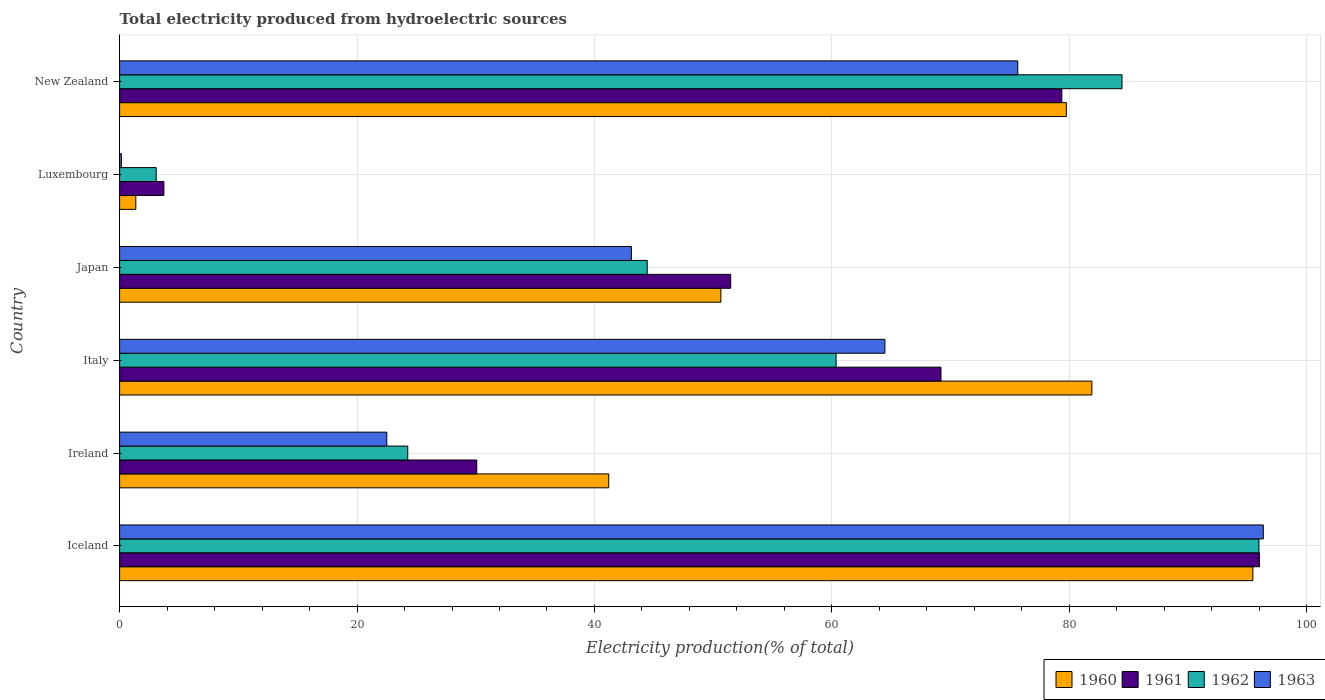How many different coloured bars are there?
Your answer should be very brief. 4. How many bars are there on the 5th tick from the bottom?
Your response must be concise. 4. In how many cases, is the number of bars for a given country not equal to the number of legend labels?
Provide a short and direct response. 0. What is the total electricity produced in 1963 in Ireland?
Give a very brief answer. 22.51. Across all countries, what is the maximum total electricity produced in 1960?
Give a very brief answer. 95.46. Across all countries, what is the minimum total electricity produced in 1963?
Make the answer very short. 0.15. In which country was the total electricity produced in 1963 minimum?
Your answer should be compact. Luxembourg. What is the total total electricity produced in 1960 in the graph?
Provide a short and direct response. 350.33. What is the difference between the total electricity produced in 1963 in Luxembourg and that in New Zealand?
Offer a very short reply. -75.51. What is the difference between the total electricity produced in 1963 in Ireland and the total electricity produced in 1962 in Iceland?
Your answer should be compact. -73.47. What is the average total electricity produced in 1961 per country?
Make the answer very short. 54.98. What is the difference between the total electricity produced in 1963 and total electricity produced in 1961 in Japan?
Provide a succinct answer. -8.36. What is the ratio of the total electricity produced in 1963 in Ireland to that in Japan?
Make the answer very short. 0.52. Is the difference between the total electricity produced in 1963 in Ireland and Italy greater than the difference between the total electricity produced in 1961 in Ireland and Italy?
Give a very brief answer. No. What is the difference between the highest and the second highest total electricity produced in 1963?
Give a very brief answer. 20.68. What is the difference between the highest and the lowest total electricity produced in 1962?
Your response must be concise. 92.89. In how many countries, is the total electricity produced in 1962 greater than the average total electricity produced in 1962 taken over all countries?
Keep it short and to the point. 3. Is it the case that in every country, the sum of the total electricity produced in 1960 and total electricity produced in 1961 is greater than the sum of total electricity produced in 1962 and total electricity produced in 1963?
Offer a terse response. No. What does the 3rd bar from the top in Ireland represents?
Offer a terse response. 1961. Are all the bars in the graph horizontal?
Your answer should be compact. Yes. Does the graph contain grids?
Ensure brevity in your answer.  Yes. Where does the legend appear in the graph?
Keep it short and to the point. Bottom right. How many legend labels are there?
Give a very brief answer. 4. What is the title of the graph?
Provide a succinct answer. Total electricity produced from hydroelectric sources. What is the Electricity production(% of total) of 1960 in Iceland?
Give a very brief answer. 95.46. What is the Electricity production(% of total) of 1961 in Iceland?
Offer a terse response. 96.02. What is the Electricity production(% of total) in 1962 in Iceland?
Give a very brief answer. 95.97. What is the Electricity production(% of total) in 1963 in Iceland?
Keep it short and to the point. 96.34. What is the Electricity production(% of total) in 1960 in Ireland?
Your answer should be compact. 41.2. What is the Electricity production(% of total) in 1961 in Ireland?
Provide a succinct answer. 30.09. What is the Electricity production(% of total) of 1962 in Ireland?
Offer a terse response. 24.27. What is the Electricity production(% of total) in 1963 in Ireland?
Provide a short and direct response. 22.51. What is the Electricity production(% of total) of 1960 in Italy?
Your response must be concise. 81.9. What is the Electricity production(% of total) of 1961 in Italy?
Provide a short and direct response. 69.19. What is the Electricity production(% of total) in 1962 in Italy?
Keep it short and to the point. 60.35. What is the Electricity production(% of total) in 1963 in Italy?
Provide a short and direct response. 64.47. What is the Electricity production(% of total) of 1960 in Japan?
Offer a very short reply. 50.65. What is the Electricity production(% of total) in 1961 in Japan?
Make the answer very short. 51.48. What is the Electricity production(% of total) in 1962 in Japan?
Your response must be concise. 44.44. What is the Electricity production(% of total) of 1963 in Japan?
Keep it short and to the point. 43.11. What is the Electricity production(% of total) in 1960 in Luxembourg?
Your response must be concise. 1.37. What is the Electricity production(% of total) of 1961 in Luxembourg?
Offer a terse response. 3.73. What is the Electricity production(% of total) in 1962 in Luxembourg?
Offer a very short reply. 3.08. What is the Electricity production(% of total) of 1963 in Luxembourg?
Keep it short and to the point. 0.15. What is the Electricity production(% of total) of 1960 in New Zealand?
Keep it short and to the point. 79.75. What is the Electricity production(% of total) in 1961 in New Zealand?
Make the answer very short. 79.37. What is the Electricity production(% of total) in 1962 in New Zealand?
Ensure brevity in your answer.  84.44. What is the Electricity production(% of total) of 1963 in New Zealand?
Your answer should be compact. 75.66. Across all countries, what is the maximum Electricity production(% of total) in 1960?
Offer a very short reply. 95.46. Across all countries, what is the maximum Electricity production(% of total) in 1961?
Keep it short and to the point. 96.02. Across all countries, what is the maximum Electricity production(% of total) of 1962?
Provide a succinct answer. 95.97. Across all countries, what is the maximum Electricity production(% of total) of 1963?
Keep it short and to the point. 96.34. Across all countries, what is the minimum Electricity production(% of total) of 1960?
Your answer should be compact. 1.37. Across all countries, what is the minimum Electricity production(% of total) of 1961?
Your response must be concise. 3.73. Across all countries, what is the minimum Electricity production(% of total) of 1962?
Your answer should be compact. 3.08. Across all countries, what is the minimum Electricity production(% of total) of 1963?
Offer a terse response. 0.15. What is the total Electricity production(% of total) of 1960 in the graph?
Provide a short and direct response. 350.33. What is the total Electricity production(% of total) in 1961 in the graph?
Make the answer very short. 329.87. What is the total Electricity production(% of total) of 1962 in the graph?
Keep it short and to the point. 312.57. What is the total Electricity production(% of total) in 1963 in the graph?
Your response must be concise. 302.24. What is the difference between the Electricity production(% of total) in 1960 in Iceland and that in Ireland?
Keep it short and to the point. 54.26. What is the difference between the Electricity production(% of total) in 1961 in Iceland and that in Ireland?
Offer a very short reply. 65.93. What is the difference between the Electricity production(% of total) of 1962 in Iceland and that in Ireland?
Ensure brevity in your answer.  71.7. What is the difference between the Electricity production(% of total) in 1963 in Iceland and that in Ireland?
Offer a very short reply. 73.83. What is the difference between the Electricity production(% of total) in 1960 in Iceland and that in Italy?
Keep it short and to the point. 13.56. What is the difference between the Electricity production(% of total) of 1961 in Iceland and that in Italy?
Provide a short and direct response. 26.83. What is the difference between the Electricity production(% of total) in 1962 in Iceland and that in Italy?
Ensure brevity in your answer.  35.62. What is the difference between the Electricity production(% of total) in 1963 in Iceland and that in Italy?
Your response must be concise. 31.87. What is the difference between the Electricity production(% of total) of 1960 in Iceland and that in Japan?
Provide a short and direct response. 44.81. What is the difference between the Electricity production(% of total) of 1961 in Iceland and that in Japan?
Provide a short and direct response. 44.54. What is the difference between the Electricity production(% of total) in 1962 in Iceland and that in Japan?
Offer a terse response. 51.53. What is the difference between the Electricity production(% of total) in 1963 in Iceland and that in Japan?
Offer a very short reply. 53.23. What is the difference between the Electricity production(% of total) in 1960 in Iceland and that in Luxembourg?
Offer a terse response. 94.1. What is the difference between the Electricity production(% of total) in 1961 in Iceland and that in Luxembourg?
Offer a very short reply. 92.29. What is the difference between the Electricity production(% of total) of 1962 in Iceland and that in Luxembourg?
Give a very brief answer. 92.89. What is the difference between the Electricity production(% of total) in 1963 in Iceland and that in Luxembourg?
Ensure brevity in your answer.  96.19. What is the difference between the Electricity production(% of total) in 1960 in Iceland and that in New Zealand?
Give a very brief answer. 15.71. What is the difference between the Electricity production(% of total) of 1961 in Iceland and that in New Zealand?
Provide a short and direct response. 16.65. What is the difference between the Electricity production(% of total) of 1962 in Iceland and that in New Zealand?
Keep it short and to the point. 11.54. What is the difference between the Electricity production(% of total) in 1963 in Iceland and that in New Zealand?
Provide a short and direct response. 20.68. What is the difference between the Electricity production(% of total) in 1960 in Ireland and that in Italy?
Your answer should be very brief. -40.7. What is the difference between the Electricity production(% of total) in 1961 in Ireland and that in Italy?
Provide a succinct answer. -39.1. What is the difference between the Electricity production(% of total) of 1962 in Ireland and that in Italy?
Give a very brief answer. -36.08. What is the difference between the Electricity production(% of total) of 1963 in Ireland and that in Italy?
Offer a terse response. -41.96. What is the difference between the Electricity production(% of total) of 1960 in Ireland and that in Japan?
Offer a very short reply. -9.45. What is the difference between the Electricity production(% of total) in 1961 in Ireland and that in Japan?
Your answer should be very brief. -21.39. What is the difference between the Electricity production(% of total) of 1962 in Ireland and that in Japan?
Your answer should be compact. -20.17. What is the difference between the Electricity production(% of total) of 1963 in Ireland and that in Japan?
Your answer should be compact. -20.61. What is the difference between the Electricity production(% of total) in 1960 in Ireland and that in Luxembourg?
Make the answer very short. 39.84. What is the difference between the Electricity production(% of total) of 1961 in Ireland and that in Luxembourg?
Your answer should be very brief. 26.36. What is the difference between the Electricity production(% of total) in 1962 in Ireland and that in Luxembourg?
Your response must be concise. 21.19. What is the difference between the Electricity production(% of total) of 1963 in Ireland and that in Luxembourg?
Offer a very short reply. 22.36. What is the difference between the Electricity production(% of total) of 1960 in Ireland and that in New Zealand?
Provide a succinct answer. -38.55. What is the difference between the Electricity production(% of total) in 1961 in Ireland and that in New Zealand?
Offer a very short reply. -49.29. What is the difference between the Electricity production(% of total) in 1962 in Ireland and that in New Zealand?
Your answer should be compact. -60.17. What is the difference between the Electricity production(% of total) in 1963 in Ireland and that in New Zealand?
Ensure brevity in your answer.  -53.15. What is the difference between the Electricity production(% of total) of 1960 in Italy and that in Japan?
Offer a terse response. 31.25. What is the difference between the Electricity production(% of total) in 1961 in Italy and that in Japan?
Ensure brevity in your answer.  17.71. What is the difference between the Electricity production(% of total) of 1962 in Italy and that in Japan?
Keep it short and to the point. 15.91. What is the difference between the Electricity production(% of total) in 1963 in Italy and that in Japan?
Keep it short and to the point. 21.35. What is the difference between the Electricity production(% of total) in 1960 in Italy and that in Luxembourg?
Offer a very short reply. 80.53. What is the difference between the Electricity production(% of total) of 1961 in Italy and that in Luxembourg?
Provide a succinct answer. 65.46. What is the difference between the Electricity production(% of total) of 1962 in Italy and that in Luxembourg?
Your answer should be compact. 57.27. What is the difference between the Electricity production(% of total) in 1963 in Italy and that in Luxembourg?
Make the answer very short. 64.32. What is the difference between the Electricity production(% of total) of 1960 in Italy and that in New Zealand?
Offer a very short reply. 2.15. What is the difference between the Electricity production(% of total) of 1961 in Italy and that in New Zealand?
Your answer should be very brief. -10.18. What is the difference between the Electricity production(% of total) in 1962 in Italy and that in New Zealand?
Offer a terse response. -24.08. What is the difference between the Electricity production(% of total) of 1963 in Italy and that in New Zealand?
Your answer should be very brief. -11.19. What is the difference between the Electricity production(% of total) in 1960 in Japan and that in Luxembourg?
Provide a short and direct response. 49.28. What is the difference between the Electricity production(% of total) in 1961 in Japan and that in Luxembourg?
Give a very brief answer. 47.75. What is the difference between the Electricity production(% of total) of 1962 in Japan and that in Luxembourg?
Make the answer very short. 41.36. What is the difference between the Electricity production(% of total) in 1963 in Japan and that in Luxembourg?
Your answer should be compact. 42.97. What is the difference between the Electricity production(% of total) in 1960 in Japan and that in New Zealand?
Offer a very short reply. -29.1. What is the difference between the Electricity production(% of total) of 1961 in Japan and that in New Zealand?
Offer a very short reply. -27.9. What is the difference between the Electricity production(% of total) of 1962 in Japan and that in New Zealand?
Offer a very short reply. -39.99. What is the difference between the Electricity production(% of total) in 1963 in Japan and that in New Zealand?
Ensure brevity in your answer.  -32.54. What is the difference between the Electricity production(% of total) of 1960 in Luxembourg and that in New Zealand?
Offer a very short reply. -78.38. What is the difference between the Electricity production(% of total) of 1961 in Luxembourg and that in New Zealand?
Ensure brevity in your answer.  -75.64. What is the difference between the Electricity production(% of total) in 1962 in Luxembourg and that in New Zealand?
Provide a succinct answer. -81.36. What is the difference between the Electricity production(% of total) in 1963 in Luxembourg and that in New Zealand?
Give a very brief answer. -75.51. What is the difference between the Electricity production(% of total) in 1960 in Iceland and the Electricity production(% of total) in 1961 in Ireland?
Make the answer very short. 65.38. What is the difference between the Electricity production(% of total) of 1960 in Iceland and the Electricity production(% of total) of 1962 in Ireland?
Give a very brief answer. 71.19. What is the difference between the Electricity production(% of total) in 1960 in Iceland and the Electricity production(% of total) in 1963 in Ireland?
Offer a very short reply. 72.95. What is the difference between the Electricity production(% of total) in 1961 in Iceland and the Electricity production(% of total) in 1962 in Ireland?
Provide a short and direct response. 71.75. What is the difference between the Electricity production(% of total) of 1961 in Iceland and the Electricity production(% of total) of 1963 in Ireland?
Your answer should be compact. 73.51. What is the difference between the Electricity production(% of total) of 1962 in Iceland and the Electricity production(% of total) of 1963 in Ireland?
Make the answer very short. 73.47. What is the difference between the Electricity production(% of total) in 1960 in Iceland and the Electricity production(% of total) in 1961 in Italy?
Give a very brief answer. 26.27. What is the difference between the Electricity production(% of total) in 1960 in Iceland and the Electricity production(% of total) in 1962 in Italy?
Give a very brief answer. 35.11. What is the difference between the Electricity production(% of total) in 1960 in Iceland and the Electricity production(% of total) in 1963 in Italy?
Ensure brevity in your answer.  30.99. What is the difference between the Electricity production(% of total) of 1961 in Iceland and the Electricity production(% of total) of 1962 in Italy?
Make the answer very short. 35.67. What is the difference between the Electricity production(% of total) in 1961 in Iceland and the Electricity production(% of total) in 1963 in Italy?
Your answer should be compact. 31.55. What is the difference between the Electricity production(% of total) in 1962 in Iceland and the Electricity production(% of total) in 1963 in Italy?
Offer a very short reply. 31.51. What is the difference between the Electricity production(% of total) of 1960 in Iceland and the Electricity production(% of total) of 1961 in Japan?
Keep it short and to the point. 43.99. What is the difference between the Electricity production(% of total) of 1960 in Iceland and the Electricity production(% of total) of 1962 in Japan?
Your response must be concise. 51.02. What is the difference between the Electricity production(% of total) of 1960 in Iceland and the Electricity production(% of total) of 1963 in Japan?
Your answer should be compact. 52.35. What is the difference between the Electricity production(% of total) in 1961 in Iceland and the Electricity production(% of total) in 1962 in Japan?
Ensure brevity in your answer.  51.58. What is the difference between the Electricity production(% of total) in 1961 in Iceland and the Electricity production(% of total) in 1963 in Japan?
Your answer should be compact. 52.91. What is the difference between the Electricity production(% of total) in 1962 in Iceland and the Electricity production(% of total) in 1963 in Japan?
Make the answer very short. 52.86. What is the difference between the Electricity production(% of total) in 1960 in Iceland and the Electricity production(% of total) in 1961 in Luxembourg?
Offer a very short reply. 91.73. What is the difference between the Electricity production(% of total) of 1960 in Iceland and the Electricity production(% of total) of 1962 in Luxembourg?
Offer a very short reply. 92.38. What is the difference between the Electricity production(% of total) of 1960 in Iceland and the Electricity production(% of total) of 1963 in Luxembourg?
Offer a terse response. 95.32. What is the difference between the Electricity production(% of total) in 1961 in Iceland and the Electricity production(% of total) in 1962 in Luxembourg?
Provide a short and direct response. 92.94. What is the difference between the Electricity production(% of total) in 1961 in Iceland and the Electricity production(% of total) in 1963 in Luxembourg?
Offer a terse response. 95.87. What is the difference between the Electricity production(% of total) of 1962 in Iceland and the Electricity production(% of total) of 1963 in Luxembourg?
Your answer should be very brief. 95.83. What is the difference between the Electricity production(% of total) in 1960 in Iceland and the Electricity production(% of total) in 1961 in New Zealand?
Your answer should be very brief. 16.09. What is the difference between the Electricity production(% of total) of 1960 in Iceland and the Electricity production(% of total) of 1962 in New Zealand?
Give a very brief answer. 11.02. What is the difference between the Electricity production(% of total) in 1960 in Iceland and the Electricity production(% of total) in 1963 in New Zealand?
Provide a short and direct response. 19.8. What is the difference between the Electricity production(% of total) of 1961 in Iceland and the Electricity production(% of total) of 1962 in New Zealand?
Your answer should be compact. 11.58. What is the difference between the Electricity production(% of total) of 1961 in Iceland and the Electricity production(% of total) of 1963 in New Zealand?
Your answer should be very brief. 20.36. What is the difference between the Electricity production(% of total) of 1962 in Iceland and the Electricity production(% of total) of 1963 in New Zealand?
Ensure brevity in your answer.  20.32. What is the difference between the Electricity production(% of total) of 1960 in Ireland and the Electricity production(% of total) of 1961 in Italy?
Make the answer very short. -27.99. What is the difference between the Electricity production(% of total) in 1960 in Ireland and the Electricity production(% of total) in 1962 in Italy?
Make the answer very short. -19.15. What is the difference between the Electricity production(% of total) in 1960 in Ireland and the Electricity production(% of total) in 1963 in Italy?
Give a very brief answer. -23.27. What is the difference between the Electricity production(% of total) of 1961 in Ireland and the Electricity production(% of total) of 1962 in Italy?
Offer a terse response. -30.27. What is the difference between the Electricity production(% of total) in 1961 in Ireland and the Electricity production(% of total) in 1963 in Italy?
Keep it short and to the point. -34.38. What is the difference between the Electricity production(% of total) of 1962 in Ireland and the Electricity production(% of total) of 1963 in Italy?
Offer a very short reply. -40.2. What is the difference between the Electricity production(% of total) in 1960 in Ireland and the Electricity production(% of total) in 1961 in Japan?
Your answer should be very brief. -10.27. What is the difference between the Electricity production(% of total) of 1960 in Ireland and the Electricity production(% of total) of 1962 in Japan?
Ensure brevity in your answer.  -3.24. What is the difference between the Electricity production(% of total) in 1960 in Ireland and the Electricity production(% of total) in 1963 in Japan?
Ensure brevity in your answer.  -1.91. What is the difference between the Electricity production(% of total) in 1961 in Ireland and the Electricity production(% of total) in 1962 in Japan?
Give a very brief answer. -14.36. What is the difference between the Electricity production(% of total) in 1961 in Ireland and the Electricity production(% of total) in 1963 in Japan?
Offer a very short reply. -13.03. What is the difference between the Electricity production(% of total) of 1962 in Ireland and the Electricity production(% of total) of 1963 in Japan?
Make the answer very short. -18.84. What is the difference between the Electricity production(% of total) of 1960 in Ireland and the Electricity production(% of total) of 1961 in Luxembourg?
Your response must be concise. 37.47. What is the difference between the Electricity production(% of total) in 1960 in Ireland and the Electricity production(% of total) in 1962 in Luxembourg?
Provide a short and direct response. 38.12. What is the difference between the Electricity production(% of total) of 1960 in Ireland and the Electricity production(% of total) of 1963 in Luxembourg?
Provide a short and direct response. 41.05. What is the difference between the Electricity production(% of total) in 1961 in Ireland and the Electricity production(% of total) in 1962 in Luxembourg?
Offer a terse response. 27. What is the difference between the Electricity production(% of total) in 1961 in Ireland and the Electricity production(% of total) in 1963 in Luxembourg?
Keep it short and to the point. 29.94. What is the difference between the Electricity production(% of total) in 1962 in Ireland and the Electricity production(% of total) in 1963 in Luxembourg?
Ensure brevity in your answer.  24.12. What is the difference between the Electricity production(% of total) in 1960 in Ireland and the Electricity production(% of total) in 1961 in New Zealand?
Provide a short and direct response. -38.17. What is the difference between the Electricity production(% of total) of 1960 in Ireland and the Electricity production(% of total) of 1962 in New Zealand?
Provide a succinct answer. -43.24. What is the difference between the Electricity production(% of total) in 1960 in Ireland and the Electricity production(% of total) in 1963 in New Zealand?
Make the answer very short. -34.46. What is the difference between the Electricity production(% of total) of 1961 in Ireland and the Electricity production(% of total) of 1962 in New Zealand?
Make the answer very short. -54.35. What is the difference between the Electricity production(% of total) in 1961 in Ireland and the Electricity production(% of total) in 1963 in New Zealand?
Give a very brief answer. -45.57. What is the difference between the Electricity production(% of total) of 1962 in Ireland and the Electricity production(% of total) of 1963 in New Zealand?
Your response must be concise. -51.39. What is the difference between the Electricity production(% of total) of 1960 in Italy and the Electricity production(% of total) of 1961 in Japan?
Your response must be concise. 30.42. What is the difference between the Electricity production(% of total) of 1960 in Italy and the Electricity production(% of total) of 1962 in Japan?
Offer a terse response. 37.46. What is the difference between the Electricity production(% of total) in 1960 in Italy and the Electricity production(% of total) in 1963 in Japan?
Your answer should be very brief. 38.79. What is the difference between the Electricity production(% of total) of 1961 in Italy and the Electricity production(% of total) of 1962 in Japan?
Provide a succinct answer. 24.75. What is the difference between the Electricity production(% of total) in 1961 in Italy and the Electricity production(% of total) in 1963 in Japan?
Your answer should be compact. 26.08. What is the difference between the Electricity production(% of total) in 1962 in Italy and the Electricity production(% of total) in 1963 in Japan?
Give a very brief answer. 17.24. What is the difference between the Electricity production(% of total) in 1960 in Italy and the Electricity production(% of total) in 1961 in Luxembourg?
Your response must be concise. 78.17. What is the difference between the Electricity production(% of total) in 1960 in Italy and the Electricity production(% of total) in 1962 in Luxembourg?
Offer a terse response. 78.82. What is the difference between the Electricity production(% of total) in 1960 in Italy and the Electricity production(% of total) in 1963 in Luxembourg?
Keep it short and to the point. 81.75. What is the difference between the Electricity production(% of total) of 1961 in Italy and the Electricity production(% of total) of 1962 in Luxembourg?
Give a very brief answer. 66.11. What is the difference between the Electricity production(% of total) in 1961 in Italy and the Electricity production(% of total) in 1963 in Luxembourg?
Offer a terse response. 69.04. What is the difference between the Electricity production(% of total) of 1962 in Italy and the Electricity production(% of total) of 1963 in Luxembourg?
Your response must be concise. 60.21. What is the difference between the Electricity production(% of total) of 1960 in Italy and the Electricity production(% of total) of 1961 in New Zealand?
Offer a terse response. 2.53. What is the difference between the Electricity production(% of total) of 1960 in Italy and the Electricity production(% of total) of 1962 in New Zealand?
Ensure brevity in your answer.  -2.54. What is the difference between the Electricity production(% of total) in 1960 in Italy and the Electricity production(% of total) in 1963 in New Zealand?
Your response must be concise. 6.24. What is the difference between the Electricity production(% of total) in 1961 in Italy and the Electricity production(% of total) in 1962 in New Zealand?
Provide a short and direct response. -15.25. What is the difference between the Electricity production(% of total) in 1961 in Italy and the Electricity production(% of total) in 1963 in New Zealand?
Give a very brief answer. -6.47. What is the difference between the Electricity production(% of total) of 1962 in Italy and the Electricity production(% of total) of 1963 in New Zealand?
Provide a short and direct response. -15.3. What is the difference between the Electricity production(% of total) in 1960 in Japan and the Electricity production(% of total) in 1961 in Luxembourg?
Give a very brief answer. 46.92. What is the difference between the Electricity production(% of total) of 1960 in Japan and the Electricity production(% of total) of 1962 in Luxembourg?
Keep it short and to the point. 47.57. What is the difference between the Electricity production(% of total) in 1960 in Japan and the Electricity production(% of total) in 1963 in Luxembourg?
Give a very brief answer. 50.5. What is the difference between the Electricity production(% of total) of 1961 in Japan and the Electricity production(% of total) of 1962 in Luxembourg?
Offer a very short reply. 48.39. What is the difference between the Electricity production(% of total) of 1961 in Japan and the Electricity production(% of total) of 1963 in Luxembourg?
Your answer should be compact. 51.33. What is the difference between the Electricity production(% of total) of 1962 in Japan and the Electricity production(% of total) of 1963 in Luxembourg?
Ensure brevity in your answer.  44.3. What is the difference between the Electricity production(% of total) in 1960 in Japan and the Electricity production(% of total) in 1961 in New Zealand?
Provide a short and direct response. -28.72. What is the difference between the Electricity production(% of total) in 1960 in Japan and the Electricity production(% of total) in 1962 in New Zealand?
Provide a succinct answer. -33.79. What is the difference between the Electricity production(% of total) of 1960 in Japan and the Electricity production(% of total) of 1963 in New Zealand?
Provide a short and direct response. -25.01. What is the difference between the Electricity production(% of total) in 1961 in Japan and the Electricity production(% of total) in 1962 in New Zealand?
Ensure brevity in your answer.  -32.96. What is the difference between the Electricity production(% of total) in 1961 in Japan and the Electricity production(% of total) in 1963 in New Zealand?
Give a very brief answer. -24.18. What is the difference between the Electricity production(% of total) in 1962 in Japan and the Electricity production(% of total) in 1963 in New Zealand?
Provide a succinct answer. -31.21. What is the difference between the Electricity production(% of total) in 1960 in Luxembourg and the Electricity production(% of total) in 1961 in New Zealand?
Give a very brief answer. -78.01. What is the difference between the Electricity production(% of total) in 1960 in Luxembourg and the Electricity production(% of total) in 1962 in New Zealand?
Your response must be concise. -83.07. What is the difference between the Electricity production(% of total) in 1960 in Luxembourg and the Electricity production(% of total) in 1963 in New Zealand?
Make the answer very short. -74.29. What is the difference between the Electricity production(% of total) in 1961 in Luxembourg and the Electricity production(% of total) in 1962 in New Zealand?
Offer a very short reply. -80.71. What is the difference between the Electricity production(% of total) of 1961 in Luxembourg and the Electricity production(% of total) of 1963 in New Zealand?
Provide a short and direct response. -71.93. What is the difference between the Electricity production(% of total) in 1962 in Luxembourg and the Electricity production(% of total) in 1963 in New Zealand?
Your response must be concise. -72.58. What is the average Electricity production(% of total) in 1960 per country?
Your response must be concise. 58.39. What is the average Electricity production(% of total) in 1961 per country?
Offer a very short reply. 54.98. What is the average Electricity production(% of total) of 1962 per country?
Offer a terse response. 52.09. What is the average Electricity production(% of total) of 1963 per country?
Keep it short and to the point. 50.37. What is the difference between the Electricity production(% of total) in 1960 and Electricity production(% of total) in 1961 in Iceland?
Your answer should be compact. -0.56. What is the difference between the Electricity production(% of total) of 1960 and Electricity production(% of total) of 1962 in Iceland?
Ensure brevity in your answer.  -0.51. What is the difference between the Electricity production(% of total) of 1960 and Electricity production(% of total) of 1963 in Iceland?
Offer a terse response. -0.88. What is the difference between the Electricity production(% of total) of 1961 and Electricity production(% of total) of 1962 in Iceland?
Offer a terse response. 0.05. What is the difference between the Electricity production(% of total) of 1961 and Electricity production(% of total) of 1963 in Iceland?
Your response must be concise. -0.32. What is the difference between the Electricity production(% of total) in 1962 and Electricity production(% of total) in 1963 in Iceland?
Your response must be concise. -0.37. What is the difference between the Electricity production(% of total) in 1960 and Electricity production(% of total) in 1961 in Ireland?
Provide a short and direct response. 11.12. What is the difference between the Electricity production(% of total) in 1960 and Electricity production(% of total) in 1962 in Ireland?
Offer a terse response. 16.93. What is the difference between the Electricity production(% of total) of 1960 and Electricity production(% of total) of 1963 in Ireland?
Make the answer very short. 18.69. What is the difference between the Electricity production(% of total) in 1961 and Electricity production(% of total) in 1962 in Ireland?
Offer a very short reply. 5.81. What is the difference between the Electricity production(% of total) of 1961 and Electricity production(% of total) of 1963 in Ireland?
Your response must be concise. 7.58. What is the difference between the Electricity production(% of total) of 1962 and Electricity production(% of total) of 1963 in Ireland?
Your response must be concise. 1.76. What is the difference between the Electricity production(% of total) in 1960 and Electricity production(% of total) in 1961 in Italy?
Provide a short and direct response. 12.71. What is the difference between the Electricity production(% of total) of 1960 and Electricity production(% of total) of 1962 in Italy?
Ensure brevity in your answer.  21.55. What is the difference between the Electricity production(% of total) in 1960 and Electricity production(% of total) in 1963 in Italy?
Your response must be concise. 17.43. What is the difference between the Electricity production(% of total) in 1961 and Electricity production(% of total) in 1962 in Italy?
Offer a terse response. 8.84. What is the difference between the Electricity production(% of total) in 1961 and Electricity production(% of total) in 1963 in Italy?
Keep it short and to the point. 4.72. What is the difference between the Electricity production(% of total) in 1962 and Electricity production(% of total) in 1963 in Italy?
Your response must be concise. -4.11. What is the difference between the Electricity production(% of total) of 1960 and Electricity production(% of total) of 1961 in Japan?
Provide a succinct answer. -0.83. What is the difference between the Electricity production(% of total) in 1960 and Electricity production(% of total) in 1962 in Japan?
Provide a succinct answer. 6.2. What is the difference between the Electricity production(% of total) in 1960 and Electricity production(% of total) in 1963 in Japan?
Keep it short and to the point. 7.54. What is the difference between the Electricity production(% of total) in 1961 and Electricity production(% of total) in 1962 in Japan?
Give a very brief answer. 7.03. What is the difference between the Electricity production(% of total) in 1961 and Electricity production(% of total) in 1963 in Japan?
Offer a very short reply. 8.36. What is the difference between the Electricity production(% of total) in 1962 and Electricity production(% of total) in 1963 in Japan?
Provide a short and direct response. 1.33. What is the difference between the Electricity production(% of total) in 1960 and Electricity production(% of total) in 1961 in Luxembourg?
Offer a terse response. -2.36. What is the difference between the Electricity production(% of total) of 1960 and Electricity production(% of total) of 1962 in Luxembourg?
Make the answer very short. -1.72. What is the difference between the Electricity production(% of total) in 1960 and Electricity production(% of total) in 1963 in Luxembourg?
Offer a terse response. 1.22. What is the difference between the Electricity production(% of total) of 1961 and Electricity production(% of total) of 1962 in Luxembourg?
Provide a succinct answer. 0.65. What is the difference between the Electricity production(% of total) of 1961 and Electricity production(% of total) of 1963 in Luxembourg?
Your answer should be very brief. 3.58. What is the difference between the Electricity production(% of total) in 1962 and Electricity production(% of total) in 1963 in Luxembourg?
Give a very brief answer. 2.93. What is the difference between the Electricity production(% of total) in 1960 and Electricity production(% of total) in 1961 in New Zealand?
Give a very brief answer. 0.38. What is the difference between the Electricity production(% of total) of 1960 and Electricity production(% of total) of 1962 in New Zealand?
Your response must be concise. -4.69. What is the difference between the Electricity production(% of total) of 1960 and Electricity production(% of total) of 1963 in New Zealand?
Your response must be concise. 4.09. What is the difference between the Electricity production(% of total) of 1961 and Electricity production(% of total) of 1962 in New Zealand?
Your response must be concise. -5.07. What is the difference between the Electricity production(% of total) of 1961 and Electricity production(% of total) of 1963 in New Zealand?
Give a very brief answer. 3.71. What is the difference between the Electricity production(% of total) of 1962 and Electricity production(% of total) of 1963 in New Zealand?
Keep it short and to the point. 8.78. What is the ratio of the Electricity production(% of total) in 1960 in Iceland to that in Ireland?
Provide a short and direct response. 2.32. What is the ratio of the Electricity production(% of total) of 1961 in Iceland to that in Ireland?
Make the answer very short. 3.19. What is the ratio of the Electricity production(% of total) of 1962 in Iceland to that in Ireland?
Make the answer very short. 3.95. What is the ratio of the Electricity production(% of total) of 1963 in Iceland to that in Ireland?
Provide a succinct answer. 4.28. What is the ratio of the Electricity production(% of total) of 1960 in Iceland to that in Italy?
Your answer should be very brief. 1.17. What is the ratio of the Electricity production(% of total) of 1961 in Iceland to that in Italy?
Ensure brevity in your answer.  1.39. What is the ratio of the Electricity production(% of total) in 1962 in Iceland to that in Italy?
Ensure brevity in your answer.  1.59. What is the ratio of the Electricity production(% of total) in 1963 in Iceland to that in Italy?
Offer a terse response. 1.49. What is the ratio of the Electricity production(% of total) of 1960 in Iceland to that in Japan?
Provide a short and direct response. 1.88. What is the ratio of the Electricity production(% of total) of 1961 in Iceland to that in Japan?
Offer a very short reply. 1.87. What is the ratio of the Electricity production(% of total) of 1962 in Iceland to that in Japan?
Offer a very short reply. 2.16. What is the ratio of the Electricity production(% of total) of 1963 in Iceland to that in Japan?
Ensure brevity in your answer.  2.23. What is the ratio of the Electricity production(% of total) in 1960 in Iceland to that in Luxembourg?
Provide a short and direct response. 69.88. What is the ratio of the Electricity production(% of total) in 1961 in Iceland to that in Luxembourg?
Ensure brevity in your answer.  25.74. What is the ratio of the Electricity production(% of total) in 1962 in Iceland to that in Luxembourg?
Ensure brevity in your answer.  31.14. What is the ratio of the Electricity production(% of total) of 1963 in Iceland to that in Luxembourg?
Give a very brief answer. 652.71. What is the ratio of the Electricity production(% of total) in 1960 in Iceland to that in New Zealand?
Your answer should be very brief. 1.2. What is the ratio of the Electricity production(% of total) in 1961 in Iceland to that in New Zealand?
Make the answer very short. 1.21. What is the ratio of the Electricity production(% of total) in 1962 in Iceland to that in New Zealand?
Make the answer very short. 1.14. What is the ratio of the Electricity production(% of total) in 1963 in Iceland to that in New Zealand?
Provide a short and direct response. 1.27. What is the ratio of the Electricity production(% of total) of 1960 in Ireland to that in Italy?
Your answer should be compact. 0.5. What is the ratio of the Electricity production(% of total) in 1961 in Ireland to that in Italy?
Your answer should be very brief. 0.43. What is the ratio of the Electricity production(% of total) in 1962 in Ireland to that in Italy?
Provide a short and direct response. 0.4. What is the ratio of the Electricity production(% of total) in 1963 in Ireland to that in Italy?
Give a very brief answer. 0.35. What is the ratio of the Electricity production(% of total) of 1960 in Ireland to that in Japan?
Provide a succinct answer. 0.81. What is the ratio of the Electricity production(% of total) in 1961 in Ireland to that in Japan?
Provide a succinct answer. 0.58. What is the ratio of the Electricity production(% of total) in 1962 in Ireland to that in Japan?
Provide a short and direct response. 0.55. What is the ratio of the Electricity production(% of total) in 1963 in Ireland to that in Japan?
Keep it short and to the point. 0.52. What is the ratio of the Electricity production(% of total) of 1960 in Ireland to that in Luxembourg?
Offer a terse response. 30.16. What is the ratio of the Electricity production(% of total) of 1961 in Ireland to that in Luxembourg?
Ensure brevity in your answer.  8.07. What is the ratio of the Electricity production(% of total) of 1962 in Ireland to that in Luxembourg?
Ensure brevity in your answer.  7.88. What is the ratio of the Electricity production(% of total) of 1963 in Ireland to that in Luxembourg?
Make the answer very short. 152.5. What is the ratio of the Electricity production(% of total) in 1960 in Ireland to that in New Zealand?
Keep it short and to the point. 0.52. What is the ratio of the Electricity production(% of total) of 1961 in Ireland to that in New Zealand?
Ensure brevity in your answer.  0.38. What is the ratio of the Electricity production(% of total) in 1962 in Ireland to that in New Zealand?
Keep it short and to the point. 0.29. What is the ratio of the Electricity production(% of total) in 1963 in Ireland to that in New Zealand?
Keep it short and to the point. 0.3. What is the ratio of the Electricity production(% of total) of 1960 in Italy to that in Japan?
Offer a terse response. 1.62. What is the ratio of the Electricity production(% of total) in 1961 in Italy to that in Japan?
Ensure brevity in your answer.  1.34. What is the ratio of the Electricity production(% of total) of 1962 in Italy to that in Japan?
Ensure brevity in your answer.  1.36. What is the ratio of the Electricity production(% of total) of 1963 in Italy to that in Japan?
Your response must be concise. 1.5. What is the ratio of the Electricity production(% of total) in 1960 in Italy to that in Luxembourg?
Your answer should be very brief. 59.95. What is the ratio of the Electricity production(% of total) in 1961 in Italy to that in Luxembourg?
Offer a terse response. 18.55. What is the ratio of the Electricity production(% of total) of 1962 in Italy to that in Luxembourg?
Keep it short and to the point. 19.58. What is the ratio of the Electricity production(% of total) in 1963 in Italy to that in Luxembourg?
Offer a very short reply. 436.77. What is the ratio of the Electricity production(% of total) in 1961 in Italy to that in New Zealand?
Your response must be concise. 0.87. What is the ratio of the Electricity production(% of total) of 1962 in Italy to that in New Zealand?
Provide a succinct answer. 0.71. What is the ratio of the Electricity production(% of total) of 1963 in Italy to that in New Zealand?
Provide a succinct answer. 0.85. What is the ratio of the Electricity production(% of total) in 1960 in Japan to that in Luxembourg?
Provide a succinct answer. 37.08. What is the ratio of the Electricity production(% of total) of 1961 in Japan to that in Luxembourg?
Keep it short and to the point. 13.8. What is the ratio of the Electricity production(% of total) in 1962 in Japan to that in Luxembourg?
Give a very brief answer. 14.42. What is the ratio of the Electricity production(% of total) of 1963 in Japan to that in Luxembourg?
Give a very brief answer. 292.1. What is the ratio of the Electricity production(% of total) of 1960 in Japan to that in New Zealand?
Give a very brief answer. 0.64. What is the ratio of the Electricity production(% of total) in 1961 in Japan to that in New Zealand?
Provide a short and direct response. 0.65. What is the ratio of the Electricity production(% of total) of 1962 in Japan to that in New Zealand?
Your answer should be compact. 0.53. What is the ratio of the Electricity production(% of total) of 1963 in Japan to that in New Zealand?
Provide a succinct answer. 0.57. What is the ratio of the Electricity production(% of total) of 1960 in Luxembourg to that in New Zealand?
Make the answer very short. 0.02. What is the ratio of the Electricity production(% of total) in 1961 in Luxembourg to that in New Zealand?
Make the answer very short. 0.05. What is the ratio of the Electricity production(% of total) of 1962 in Luxembourg to that in New Zealand?
Offer a terse response. 0.04. What is the ratio of the Electricity production(% of total) of 1963 in Luxembourg to that in New Zealand?
Your response must be concise. 0. What is the difference between the highest and the second highest Electricity production(% of total) of 1960?
Your response must be concise. 13.56. What is the difference between the highest and the second highest Electricity production(% of total) in 1961?
Offer a terse response. 16.65. What is the difference between the highest and the second highest Electricity production(% of total) in 1962?
Your answer should be compact. 11.54. What is the difference between the highest and the second highest Electricity production(% of total) in 1963?
Your response must be concise. 20.68. What is the difference between the highest and the lowest Electricity production(% of total) of 1960?
Offer a very short reply. 94.1. What is the difference between the highest and the lowest Electricity production(% of total) of 1961?
Your answer should be compact. 92.29. What is the difference between the highest and the lowest Electricity production(% of total) of 1962?
Keep it short and to the point. 92.89. What is the difference between the highest and the lowest Electricity production(% of total) of 1963?
Offer a terse response. 96.19. 